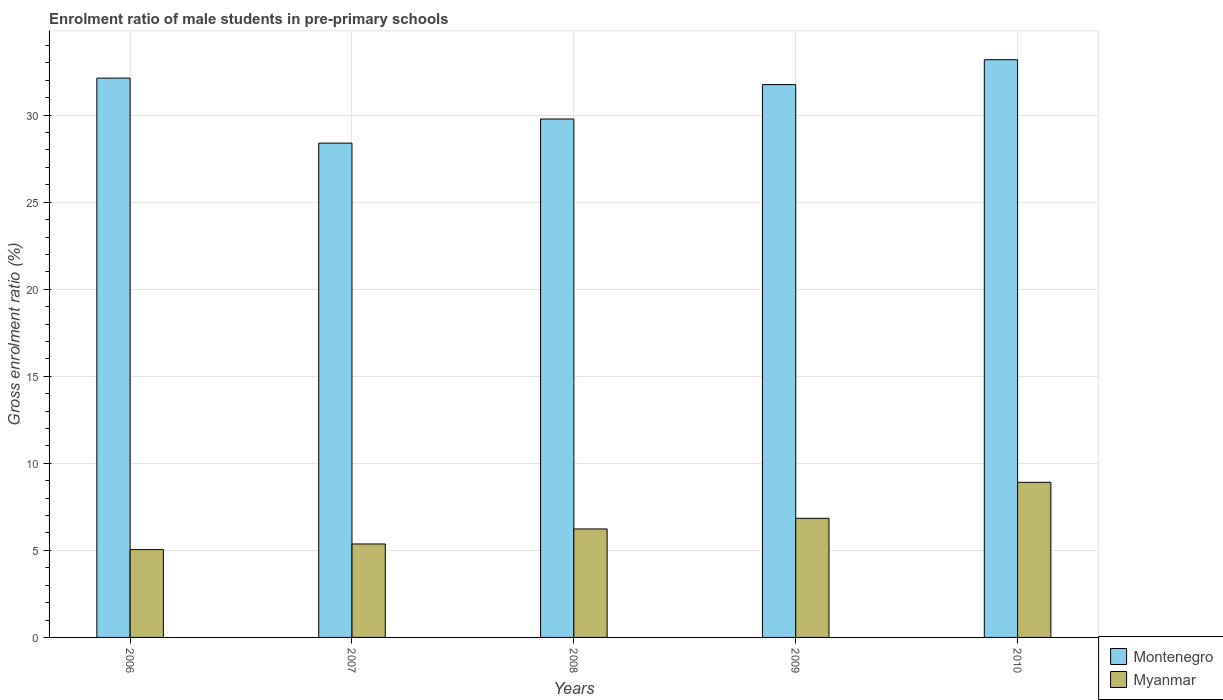How many groups of bars are there?
Your response must be concise. 5. Are the number of bars on each tick of the X-axis equal?
Give a very brief answer. Yes. How many bars are there on the 5th tick from the right?
Make the answer very short. 2. What is the enrolment ratio of male students in pre-primary schools in Myanmar in 2007?
Your answer should be very brief. 5.37. Across all years, what is the maximum enrolment ratio of male students in pre-primary schools in Montenegro?
Offer a very short reply. 33.19. Across all years, what is the minimum enrolment ratio of male students in pre-primary schools in Montenegro?
Your answer should be compact. 28.39. What is the total enrolment ratio of male students in pre-primary schools in Montenegro in the graph?
Your answer should be very brief. 155.24. What is the difference between the enrolment ratio of male students in pre-primary schools in Montenegro in 2007 and that in 2008?
Make the answer very short. -1.39. What is the difference between the enrolment ratio of male students in pre-primary schools in Myanmar in 2007 and the enrolment ratio of male students in pre-primary schools in Montenegro in 2010?
Your answer should be compact. -27.82. What is the average enrolment ratio of male students in pre-primary schools in Montenegro per year?
Your response must be concise. 31.05. In the year 2008, what is the difference between the enrolment ratio of male students in pre-primary schools in Montenegro and enrolment ratio of male students in pre-primary schools in Myanmar?
Your response must be concise. 23.55. In how many years, is the enrolment ratio of male students in pre-primary schools in Myanmar greater than 30 %?
Give a very brief answer. 0. What is the ratio of the enrolment ratio of male students in pre-primary schools in Montenegro in 2008 to that in 2010?
Provide a short and direct response. 0.9. What is the difference between the highest and the second highest enrolment ratio of male students in pre-primary schools in Montenegro?
Offer a very short reply. 1.06. What is the difference between the highest and the lowest enrolment ratio of male students in pre-primary schools in Myanmar?
Your answer should be very brief. 3.87. In how many years, is the enrolment ratio of male students in pre-primary schools in Myanmar greater than the average enrolment ratio of male students in pre-primary schools in Myanmar taken over all years?
Offer a terse response. 2. Is the sum of the enrolment ratio of male students in pre-primary schools in Myanmar in 2007 and 2009 greater than the maximum enrolment ratio of male students in pre-primary schools in Montenegro across all years?
Keep it short and to the point. No. What does the 1st bar from the left in 2009 represents?
Provide a short and direct response. Montenegro. What does the 2nd bar from the right in 2010 represents?
Provide a short and direct response. Montenegro. Are all the bars in the graph horizontal?
Provide a short and direct response. No. How many years are there in the graph?
Your answer should be very brief. 5. Where does the legend appear in the graph?
Provide a short and direct response. Bottom right. How are the legend labels stacked?
Provide a short and direct response. Vertical. What is the title of the graph?
Your response must be concise. Enrolment ratio of male students in pre-primary schools. What is the label or title of the Y-axis?
Make the answer very short. Gross enrolment ratio (%). What is the Gross enrolment ratio (%) of Montenegro in 2006?
Provide a succinct answer. 32.13. What is the Gross enrolment ratio (%) in Myanmar in 2006?
Provide a succinct answer. 5.04. What is the Gross enrolment ratio (%) in Montenegro in 2007?
Keep it short and to the point. 28.39. What is the Gross enrolment ratio (%) of Myanmar in 2007?
Offer a terse response. 5.37. What is the Gross enrolment ratio (%) in Montenegro in 2008?
Provide a succinct answer. 29.78. What is the Gross enrolment ratio (%) in Myanmar in 2008?
Your answer should be compact. 6.23. What is the Gross enrolment ratio (%) of Montenegro in 2009?
Your answer should be very brief. 31.76. What is the Gross enrolment ratio (%) in Myanmar in 2009?
Your response must be concise. 6.84. What is the Gross enrolment ratio (%) in Montenegro in 2010?
Make the answer very short. 33.19. What is the Gross enrolment ratio (%) of Myanmar in 2010?
Your answer should be very brief. 8.91. Across all years, what is the maximum Gross enrolment ratio (%) in Montenegro?
Give a very brief answer. 33.19. Across all years, what is the maximum Gross enrolment ratio (%) of Myanmar?
Your answer should be very brief. 8.91. Across all years, what is the minimum Gross enrolment ratio (%) in Montenegro?
Your response must be concise. 28.39. Across all years, what is the minimum Gross enrolment ratio (%) of Myanmar?
Provide a succinct answer. 5.04. What is the total Gross enrolment ratio (%) in Montenegro in the graph?
Your response must be concise. 155.24. What is the total Gross enrolment ratio (%) in Myanmar in the graph?
Offer a terse response. 32.4. What is the difference between the Gross enrolment ratio (%) in Montenegro in 2006 and that in 2007?
Your answer should be very brief. 3.74. What is the difference between the Gross enrolment ratio (%) in Myanmar in 2006 and that in 2007?
Your answer should be compact. -0.32. What is the difference between the Gross enrolment ratio (%) in Montenegro in 2006 and that in 2008?
Your answer should be very brief. 2.35. What is the difference between the Gross enrolment ratio (%) of Myanmar in 2006 and that in 2008?
Keep it short and to the point. -1.19. What is the difference between the Gross enrolment ratio (%) in Montenegro in 2006 and that in 2009?
Keep it short and to the point. 0.37. What is the difference between the Gross enrolment ratio (%) in Myanmar in 2006 and that in 2009?
Offer a very short reply. -1.8. What is the difference between the Gross enrolment ratio (%) in Montenegro in 2006 and that in 2010?
Your answer should be compact. -1.06. What is the difference between the Gross enrolment ratio (%) in Myanmar in 2006 and that in 2010?
Keep it short and to the point. -3.87. What is the difference between the Gross enrolment ratio (%) in Montenegro in 2007 and that in 2008?
Ensure brevity in your answer.  -1.39. What is the difference between the Gross enrolment ratio (%) in Myanmar in 2007 and that in 2008?
Your response must be concise. -0.86. What is the difference between the Gross enrolment ratio (%) in Montenegro in 2007 and that in 2009?
Your answer should be compact. -3.36. What is the difference between the Gross enrolment ratio (%) in Myanmar in 2007 and that in 2009?
Your answer should be compact. -1.47. What is the difference between the Gross enrolment ratio (%) of Montenegro in 2007 and that in 2010?
Keep it short and to the point. -4.79. What is the difference between the Gross enrolment ratio (%) in Myanmar in 2007 and that in 2010?
Give a very brief answer. -3.54. What is the difference between the Gross enrolment ratio (%) in Montenegro in 2008 and that in 2009?
Provide a succinct answer. -1.98. What is the difference between the Gross enrolment ratio (%) in Myanmar in 2008 and that in 2009?
Your answer should be very brief. -0.61. What is the difference between the Gross enrolment ratio (%) of Montenegro in 2008 and that in 2010?
Give a very brief answer. -3.41. What is the difference between the Gross enrolment ratio (%) in Myanmar in 2008 and that in 2010?
Give a very brief answer. -2.68. What is the difference between the Gross enrolment ratio (%) of Montenegro in 2009 and that in 2010?
Ensure brevity in your answer.  -1.43. What is the difference between the Gross enrolment ratio (%) of Myanmar in 2009 and that in 2010?
Your answer should be very brief. -2.07. What is the difference between the Gross enrolment ratio (%) in Montenegro in 2006 and the Gross enrolment ratio (%) in Myanmar in 2007?
Offer a terse response. 26.76. What is the difference between the Gross enrolment ratio (%) of Montenegro in 2006 and the Gross enrolment ratio (%) of Myanmar in 2008?
Offer a terse response. 25.9. What is the difference between the Gross enrolment ratio (%) of Montenegro in 2006 and the Gross enrolment ratio (%) of Myanmar in 2009?
Provide a short and direct response. 25.29. What is the difference between the Gross enrolment ratio (%) in Montenegro in 2006 and the Gross enrolment ratio (%) in Myanmar in 2010?
Keep it short and to the point. 23.22. What is the difference between the Gross enrolment ratio (%) in Montenegro in 2007 and the Gross enrolment ratio (%) in Myanmar in 2008?
Keep it short and to the point. 22.16. What is the difference between the Gross enrolment ratio (%) of Montenegro in 2007 and the Gross enrolment ratio (%) of Myanmar in 2009?
Provide a short and direct response. 21.55. What is the difference between the Gross enrolment ratio (%) in Montenegro in 2007 and the Gross enrolment ratio (%) in Myanmar in 2010?
Keep it short and to the point. 19.48. What is the difference between the Gross enrolment ratio (%) in Montenegro in 2008 and the Gross enrolment ratio (%) in Myanmar in 2009?
Provide a succinct answer. 22.94. What is the difference between the Gross enrolment ratio (%) in Montenegro in 2008 and the Gross enrolment ratio (%) in Myanmar in 2010?
Keep it short and to the point. 20.87. What is the difference between the Gross enrolment ratio (%) of Montenegro in 2009 and the Gross enrolment ratio (%) of Myanmar in 2010?
Give a very brief answer. 22.85. What is the average Gross enrolment ratio (%) in Montenegro per year?
Your answer should be very brief. 31.05. What is the average Gross enrolment ratio (%) in Myanmar per year?
Keep it short and to the point. 6.48. In the year 2006, what is the difference between the Gross enrolment ratio (%) of Montenegro and Gross enrolment ratio (%) of Myanmar?
Provide a short and direct response. 27.08. In the year 2007, what is the difference between the Gross enrolment ratio (%) in Montenegro and Gross enrolment ratio (%) in Myanmar?
Keep it short and to the point. 23.02. In the year 2008, what is the difference between the Gross enrolment ratio (%) of Montenegro and Gross enrolment ratio (%) of Myanmar?
Offer a very short reply. 23.55. In the year 2009, what is the difference between the Gross enrolment ratio (%) in Montenegro and Gross enrolment ratio (%) in Myanmar?
Ensure brevity in your answer.  24.91. In the year 2010, what is the difference between the Gross enrolment ratio (%) of Montenegro and Gross enrolment ratio (%) of Myanmar?
Give a very brief answer. 24.27. What is the ratio of the Gross enrolment ratio (%) of Montenegro in 2006 to that in 2007?
Your response must be concise. 1.13. What is the ratio of the Gross enrolment ratio (%) of Myanmar in 2006 to that in 2007?
Your answer should be compact. 0.94. What is the ratio of the Gross enrolment ratio (%) in Montenegro in 2006 to that in 2008?
Offer a terse response. 1.08. What is the ratio of the Gross enrolment ratio (%) of Myanmar in 2006 to that in 2008?
Provide a succinct answer. 0.81. What is the ratio of the Gross enrolment ratio (%) of Montenegro in 2006 to that in 2009?
Keep it short and to the point. 1.01. What is the ratio of the Gross enrolment ratio (%) in Myanmar in 2006 to that in 2009?
Provide a short and direct response. 0.74. What is the ratio of the Gross enrolment ratio (%) of Montenegro in 2006 to that in 2010?
Provide a short and direct response. 0.97. What is the ratio of the Gross enrolment ratio (%) in Myanmar in 2006 to that in 2010?
Your answer should be compact. 0.57. What is the ratio of the Gross enrolment ratio (%) of Montenegro in 2007 to that in 2008?
Your answer should be compact. 0.95. What is the ratio of the Gross enrolment ratio (%) in Myanmar in 2007 to that in 2008?
Make the answer very short. 0.86. What is the ratio of the Gross enrolment ratio (%) in Montenegro in 2007 to that in 2009?
Your answer should be compact. 0.89. What is the ratio of the Gross enrolment ratio (%) of Myanmar in 2007 to that in 2009?
Your answer should be compact. 0.78. What is the ratio of the Gross enrolment ratio (%) of Montenegro in 2007 to that in 2010?
Offer a very short reply. 0.86. What is the ratio of the Gross enrolment ratio (%) of Myanmar in 2007 to that in 2010?
Your response must be concise. 0.6. What is the ratio of the Gross enrolment ratio (%) in Montenegro in 2008 to that in 2009?
Provide a succinct answer. 0.94. What is the ratio of the Gross enrolment ratio (%) in Myanmar in 2008 to that in 2009?
Offer a very short reply. 0.91. What is the ratio of the Gross enrolment ratio (%) in Montenegro in 2008 to that in 2010?
Offer a very short reply. 0.9. What is the ratio of the Gross enrolment ratio (%) in Myanmar in 2008 to that in 2010?
Offer a very short reply. 0.7. What is the ratio of the Gross enrolment ratio (%) of Montenegro in 2009 to that in 2010?
Provide a short and direct response. 0.96. What is the ratio of the Gross enrolment ratio (%) in Myanmar in 2009 to that in 2010?
Offer a very short reply. 0.77. What is the difference between the highest and the second highest Gross enrolment ratio (%) of Montenegro?
Provide a succinct answer. 1.06. What is the difference between the highest and the second highest Gross enrolment ratio (%) in Myanmar?
Offer a terse response. 2.07. What is the difference between the highest and the lowest Gross enrolment ratio (%) in Montenegro?
Your answer should be very brief. 4.79. What is the difference between the highest and the lowest Gross enrolment ratio (%) of Myanmar?
Keep it short and to the point. 3.87. 